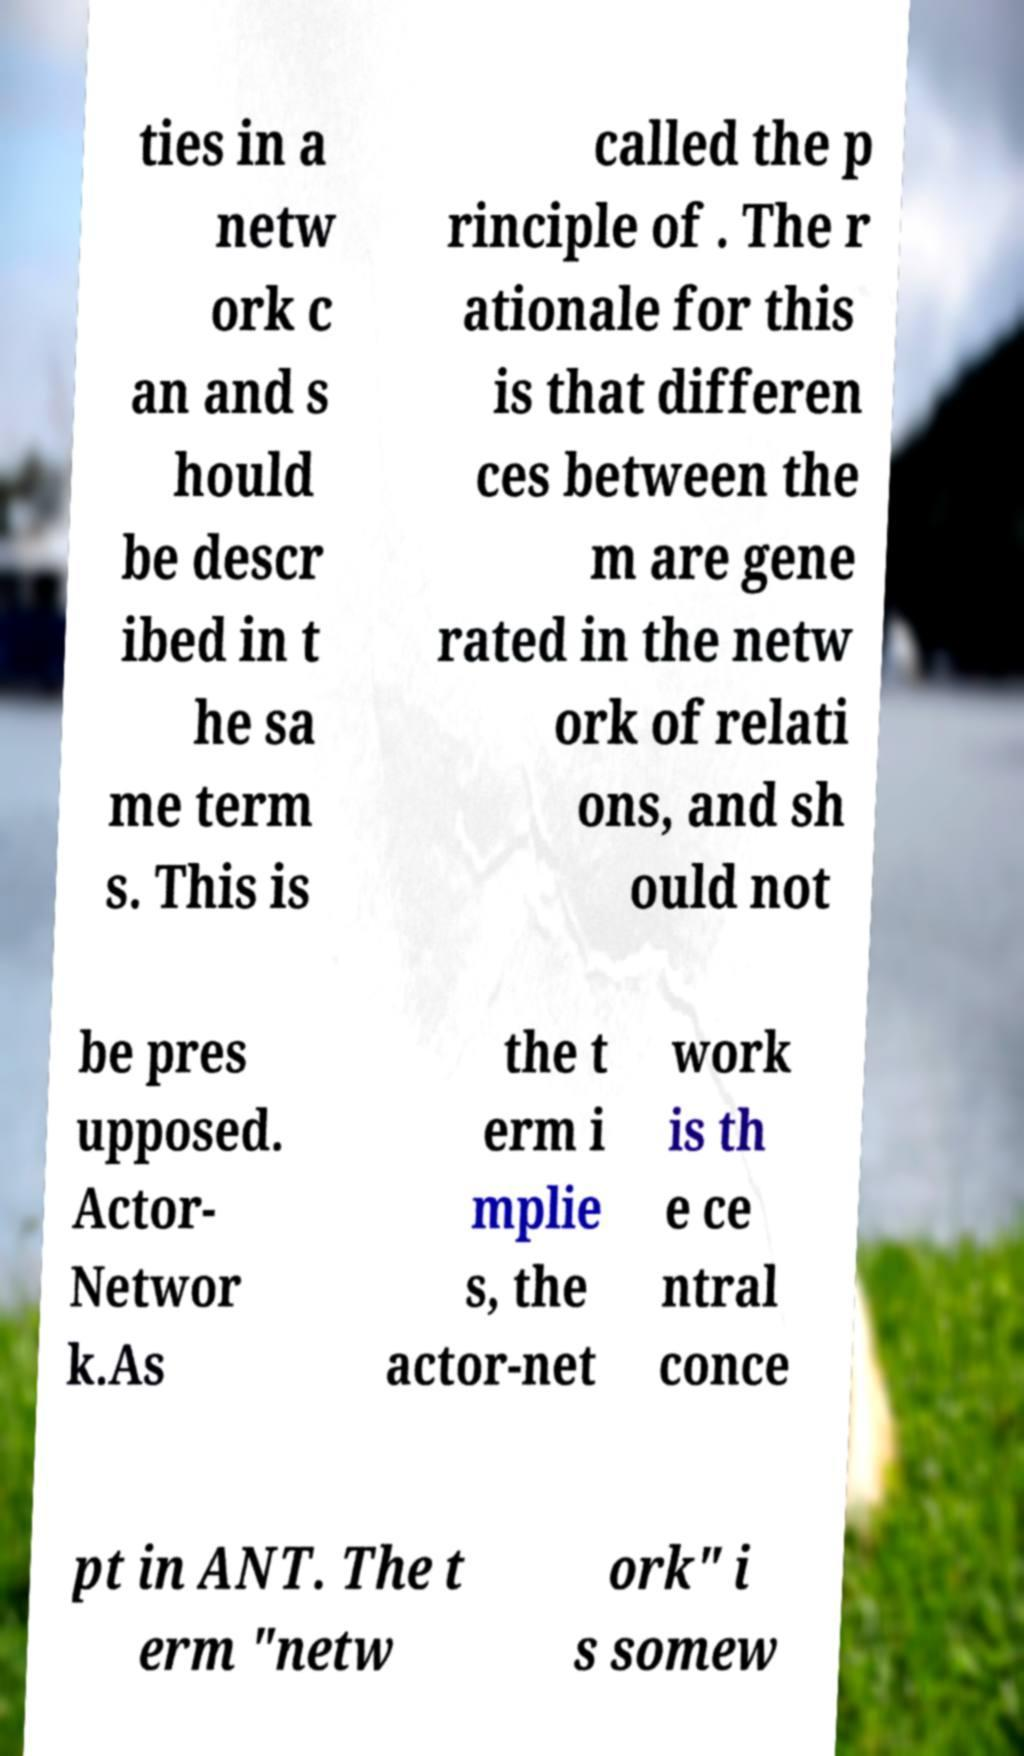Can you accurately transcribe the text from the provided image for me? ties in a netw ork c an and s hould be descr ibed in t he sa me term s. This is called the p rinciple of . The r ationale for this is that differen ces between the m are gene rated in the netw ork of relati ons, and sh ould not be pres upposed. Actor- Networ k.As the t erm i mplie s, the actor-net work is th e ce ntral conce pt in ANT. The t erm "netw ork" i s somew 